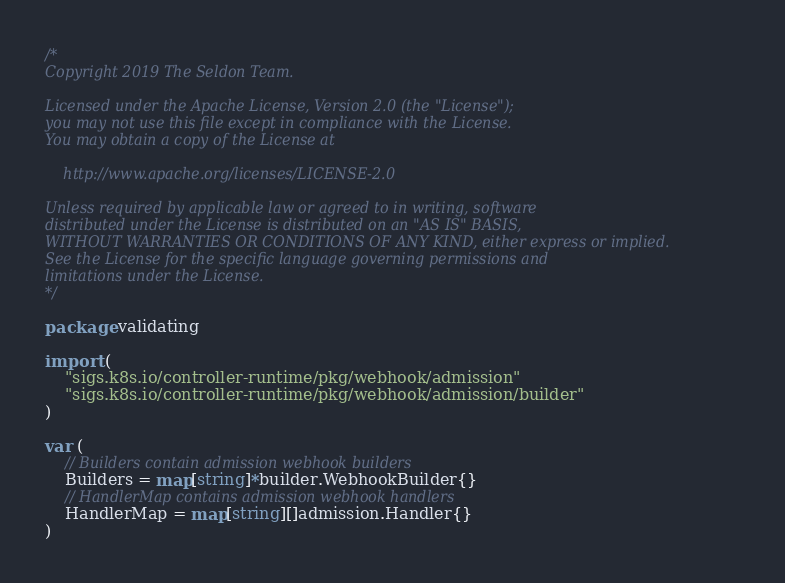<code> <loc_0><loc_0><loc_500><loc_500><_Go_>/*
Copyright 2019 The Seldon Team.

Licensed under the Apache License, Version 2.0 (the "License");
you may not use this file except in compliance with the License.
You may obtain a copy of the License at

    http://www.apache.org/licenses/LICENSE-2.0

Unless required by applicable law or agreed to in writing, software
distributed under the License is distributed on an "AS IS" BASIS,
WITHOUT WARRANTIES OR CONDITIONS OF ANY KIND, either express or implied.
See the License for the specific language governing permissions and
limitations under the License.
*/

package validating

import (
	"sigs.k8s.io/controller-runtime/pkg/webhook/admission"
	"sigs.k8s.io/controller-runtime/pkg/webhook/admission/builder"
)

var (
	// Builders contain admission webhook builders
	Builders = map[string]*builder.WebhookBuilder{}
	// HandlerMap contains admission webhook handlers
	HandlerMap = map[string][]admission.Handler{}
)
</code> 